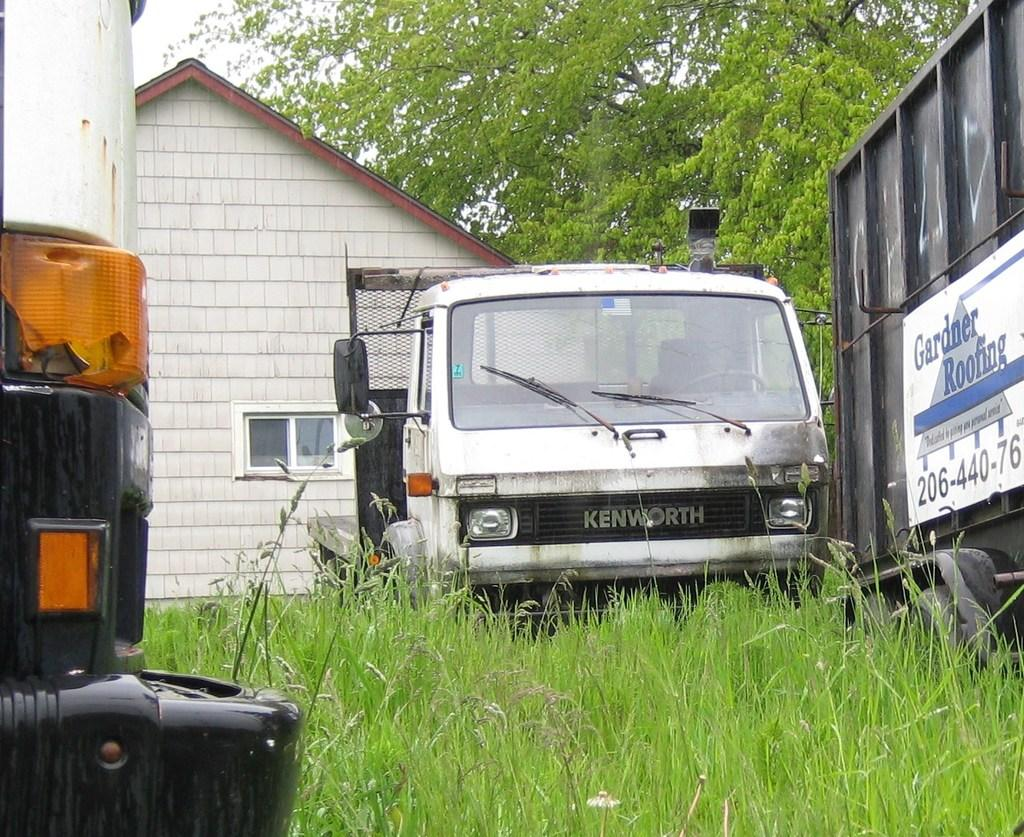Provide a one-sentence caption for the provided image. A dumpster with a logo for Gardner Roofing sits in an overgrown yard in front of a run down house. 